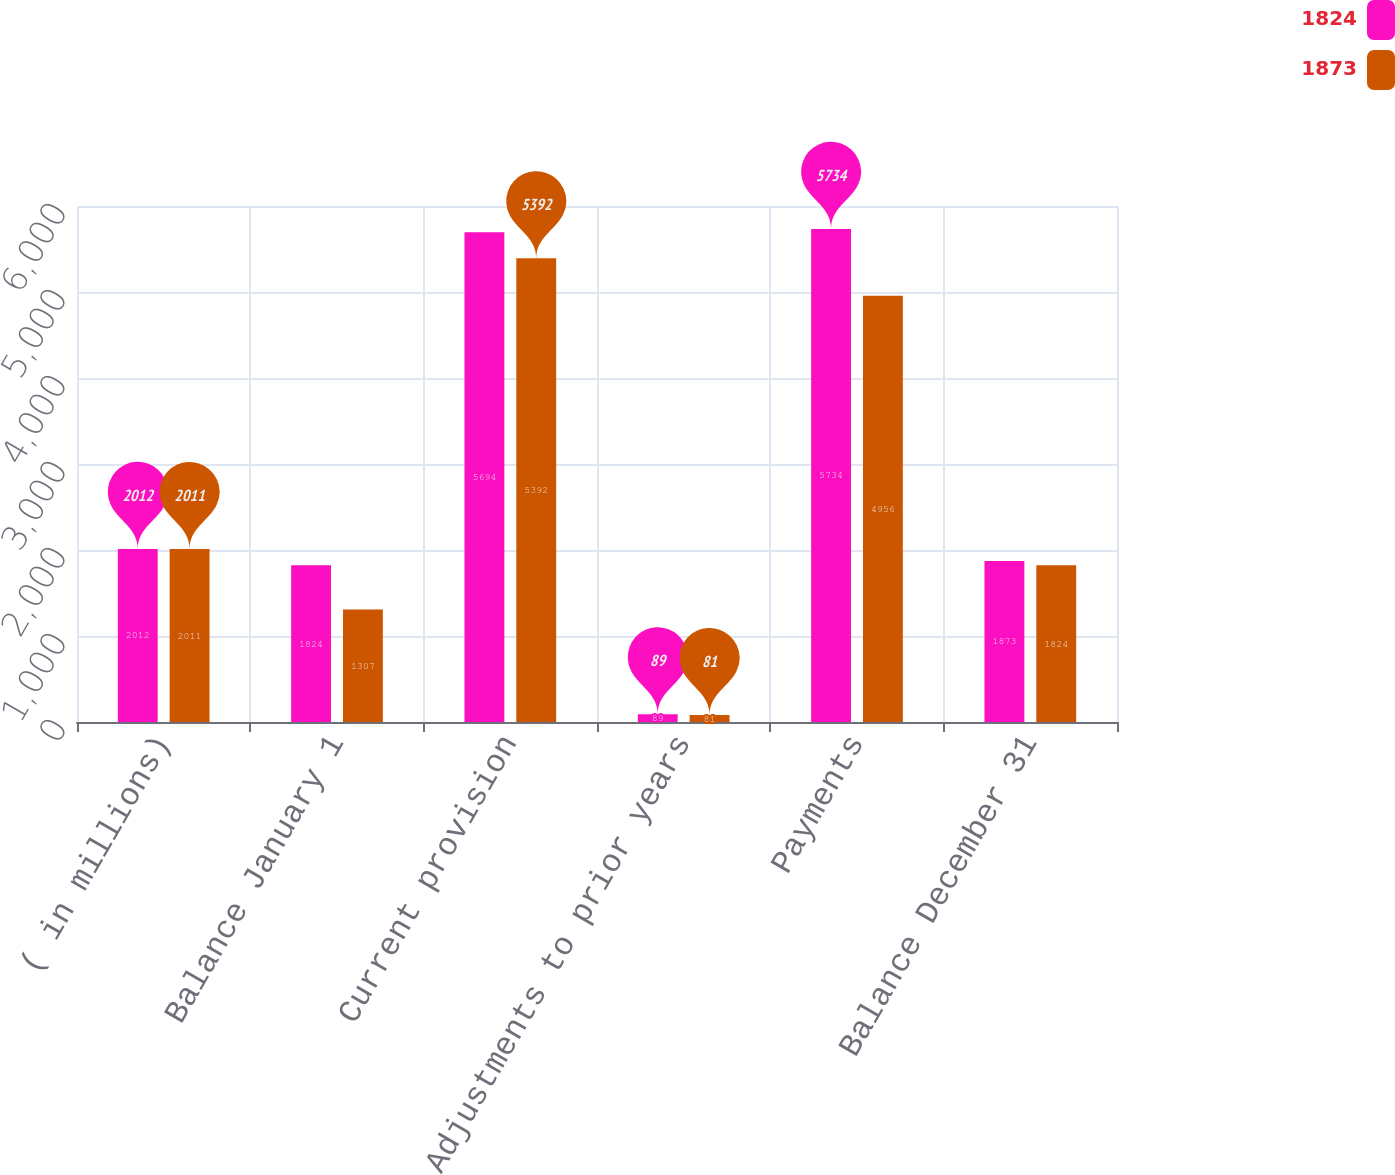<chart> <loc_0><loc_0><loc_500><loc_500><stacked_bar_chart><ecel><fcel>( in millions)<fcel>Balance January 1<fcel>Current provision<fcel>Adjustments to prior years<fcel>Payments<fcel>Balance December 31<nl><fcel>1824<fcel>2012<fcel>1824<fcel>5694<fcel>89<fcel>5734<fcel>1873<nl><fcel>1873<fcel>2011<fcel>1307<fcel>5392<fcel>81<fcel>4956<fcel>1824<nl></chart> 